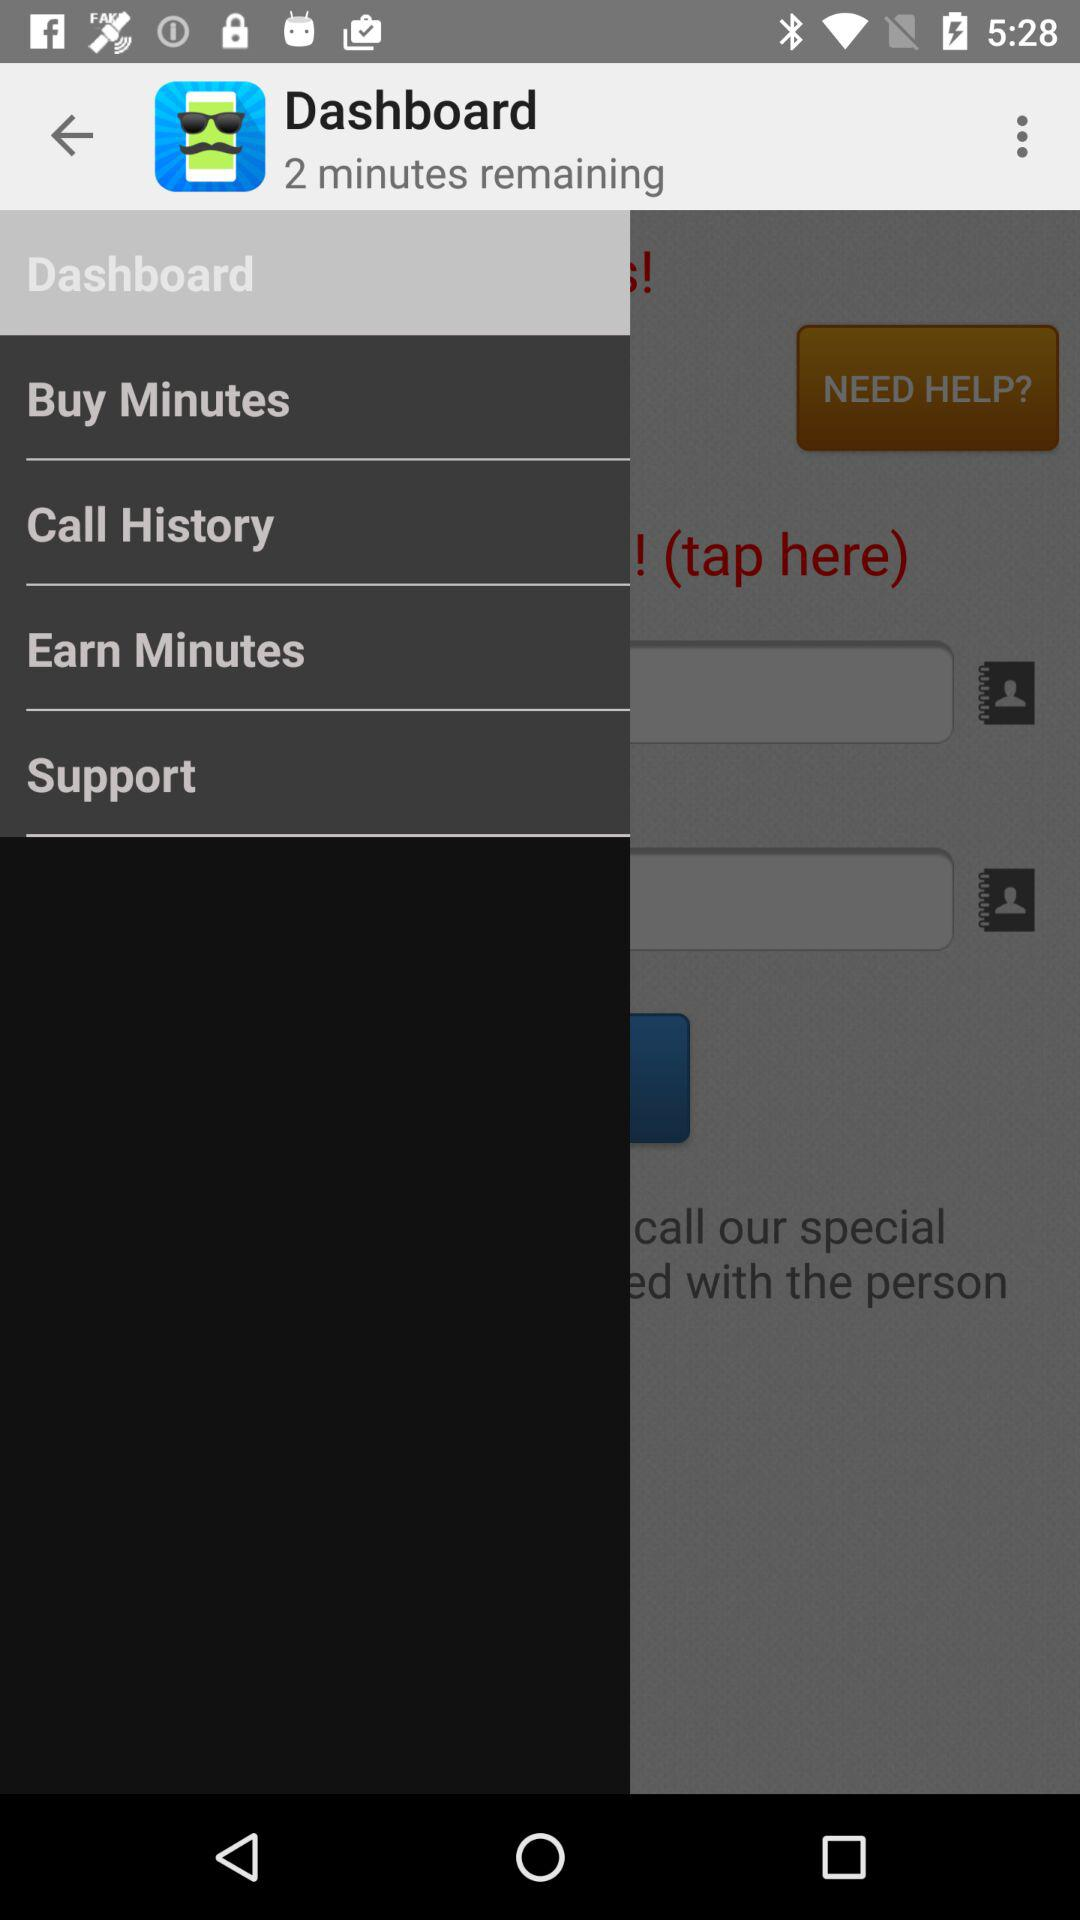How many minutes do I have remaining?
Answer the question using a single word or phrase. 2 